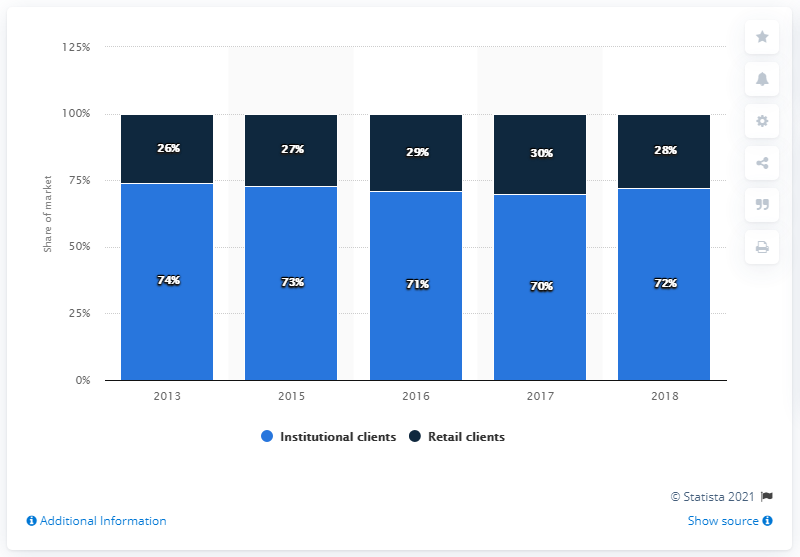Draw attention to some important aspects in this diagram. In 2016, the recorded percentage value for Institutional clients was 71%. At the end of 2018, the market share of institutional clients was 72%. To calculate the average value of all the blue bars, simply add up their values and divide the result by 10. 